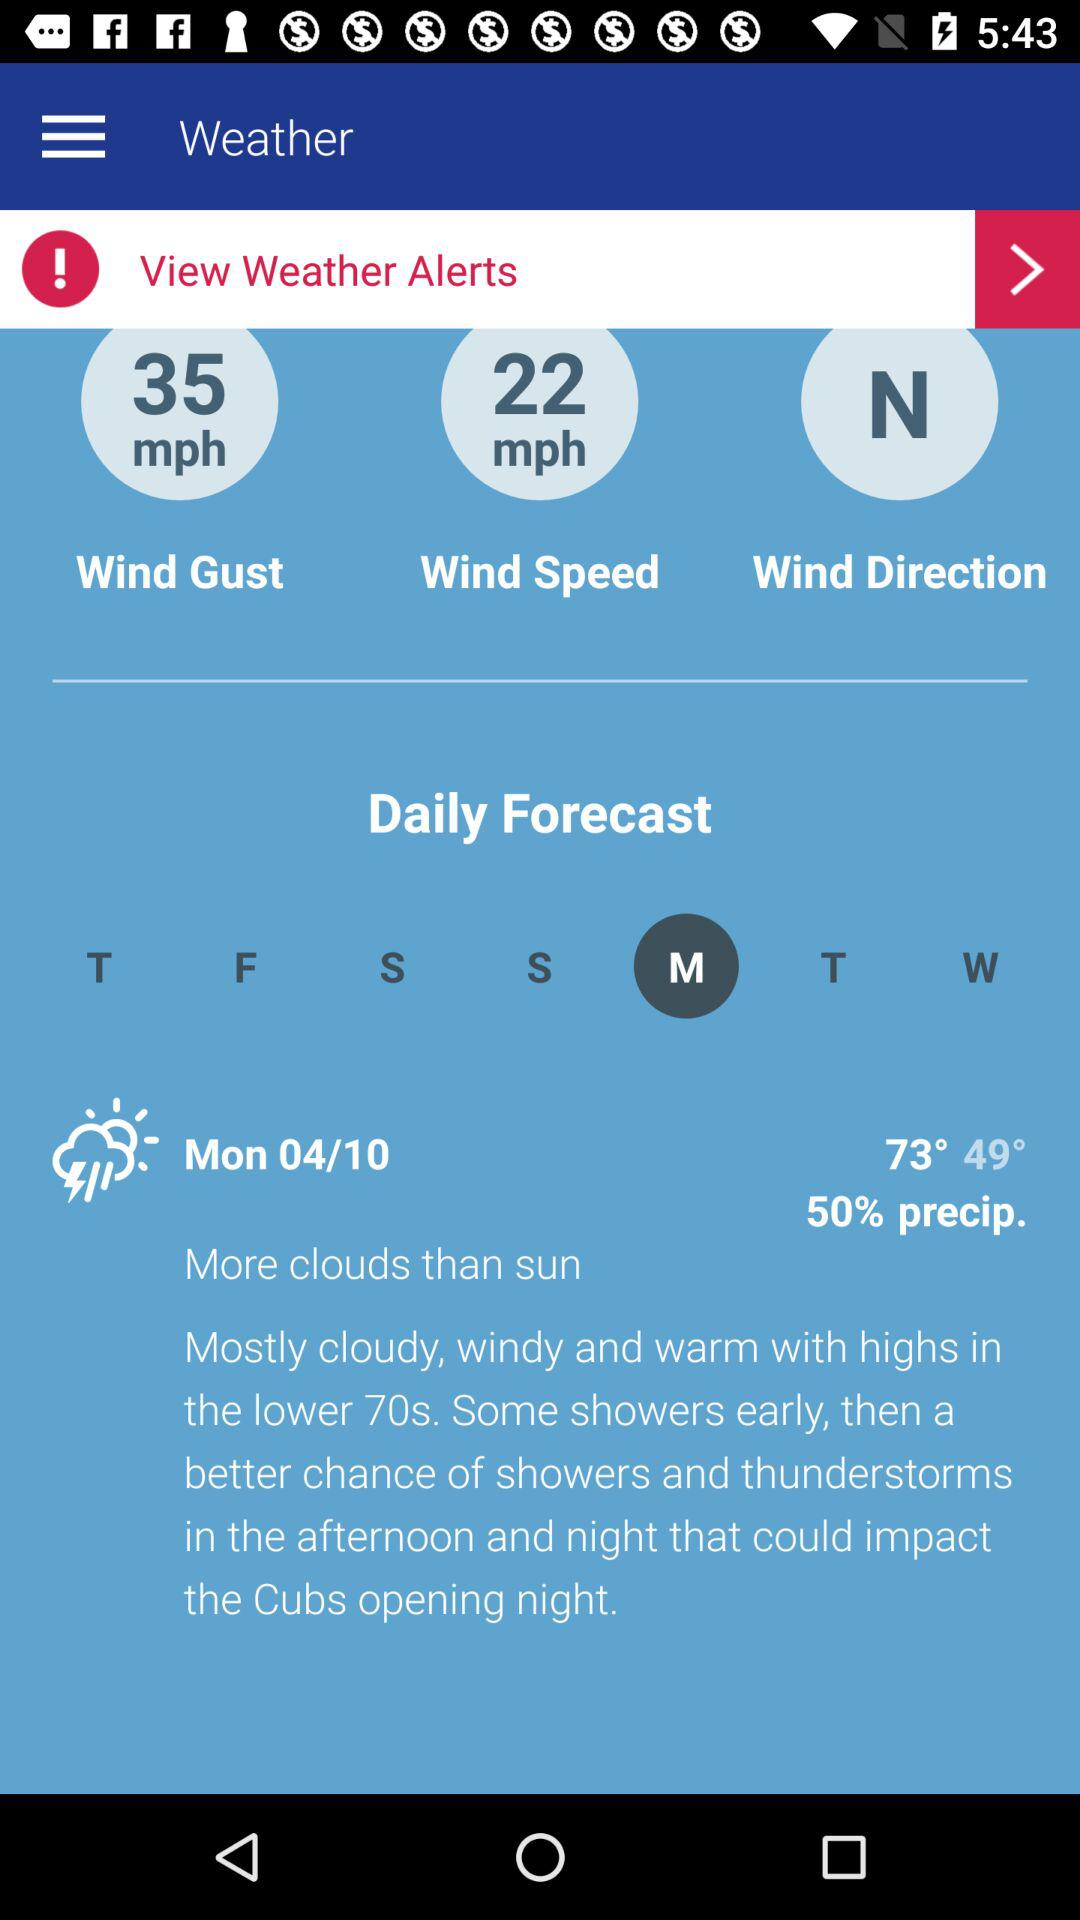What is the date? The date is Monday, 04/10. 